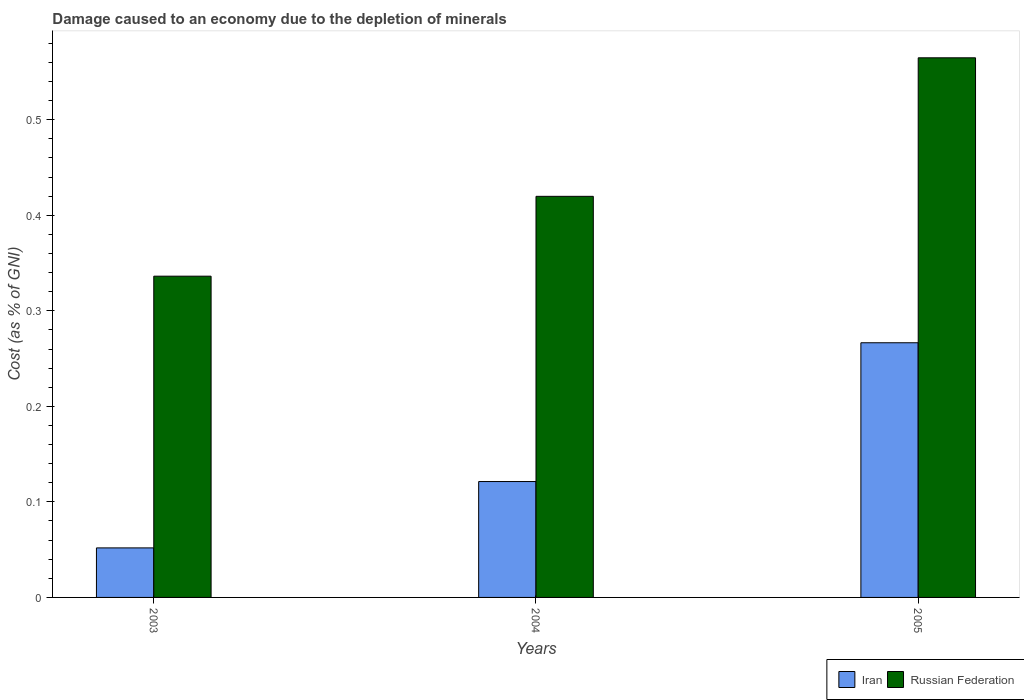How many groups of bars are there?
Give a very brief answer. 3. Are the number of bars per tick equal to the number of legend labels?
Make the answer very short. Yes. Are the number of bars on each tick of the X-axis equal?
Provide a short and direct response. Yes. What is the label of the 2nd group of bars from the left?
Offer a very short reply. 2004. In how many cases, is the number of bars for a given year not equal to the number of legend labels?
Your answer should be very brief. 0. What is the cost of damage caused due to the depletion of minerals in Iran in 2004?
Give a very brief answer. 0.12. Across all years, what is the maximum cost of damage caused due to the depletion of minerals in Russian Federation?
Provide a short and direct response. 0.56. Across all years, what is the minimum cost of damage caused due to the depletion of minerals in Russian Federation?
Provide a succinct answer. 0.34. What is the total cost of damage caused due to the depletion of minerals in Russian Federation in the graph?
Your response must be concise. 1.32. What is the difference between the cost of damage caused due to the depletion of minerals in Russian Federation in 2003 and that in 2005?
Offer a terse response. -0.23. What is the difference between the cost of damage caused due to the depletion of minerals in Russian Federation in 2003 and the cost of damage caused due to the depletion of minerals in Iran in 2004?
Offer a terse response. 0.21. What is the average cost of damage caused due to the depletion of minerals in Russian Federation per year?
Make the answer very short. 0.44. In the year 2003, what is the difference between the cost of damage caused due to the depletion of minerals in Iran and cost of damage caused due to the depletion of minerals in Russian Federation?
Provide a short and direct response. -0.28. In how many years, is the cost of damage caused due to the depletion of minerals in Russian Federation greater than 0.42000000000000004 %?
Keep it short and to the point. 1. What is the ratio of the cost of damage caused due to the depletion of minerals in Iran in 2003 to that in 2005?
Provide a short and direct response. 0.19. What is the difference between the highest and the second highest cost of damage caused due to the depletion of minerals in Russian Federation?
Offer a very short reply. 0.14. What is the difference between the highest and the lowest cost of damage caused due to the depletion of minerals in Russian Federation?
Provide a short and direct response. 0.23. What does the 2nd bar from the left in 2003 represents?
Offer a terse response. Russian Federation. What does the 2nd bar from the right in 2005 represents?
Keep it short and to the point. Iran. Are all the bars in the graph horizontal?
Make the answer very short. No. Are the values on the major ticks of Y-axis written in scientific E-notation?
Make the answer very short. No. Does the graph contain any zero values?
Ensure brevity in your answer.  No. Does the graph contain grids?
Offer a terse response. No. What is the title of the graph?
Your answer should be compact. Damage caused to an economy due to the depletion of minerals. Does "Chad" appear as one of the legend labels in the graph?
Keep it short and to the point. No. What is the label or title of the X-axis?
Your answer should be compact. Years. What is the label or title of the Y-axis?
Make the answer very short. Cost (as % of GNI). What is the Cost (as % of GNI) in Iran in 2003?
Keep it short and to the point. 0.05. What is the Cost (as % of GNI) in Russian Federation in 2003?
Your response must be concise. 0.34. What is the Cost (as % of GNI) in Iran in 2004?
Keep it short and to the point. 0.12. What is the Cost (as % of GNI) in Russian Federation in 2004?
Offer a terse response. 0.42. What is the Cost (as % of GNI) in Iran in 2005?
Make the answer very short. 0.27. What is the Cost (as % of GNI) in Russian Federation in 2005?
Offer a very short reply. 0.56. Across all years, what is the maximum Cost (as % of GNI) in Iran?
Provide a short and direct response. 0.27. Across all years, what is the maximum Cost (as % of GNI) of Russian Federation?
Provide a short and direct response. 0.56. Across all years, what is the minimum Cost (as % of GNI) in Iran?
Make the answer very short. 0.05. Across all years, what is the minimum Cost (as % of GNI) in Russian Federation?
Provide a succinct answer. 0.34. What is the total Cost (as % of GNI) of Iran in the graph?
Offer a very short reply. 0.44. What is the total Cost (as % of GNI) of Russian Federation in the graph?
Offer a very short reply. 1.32. What is the difference between the Cost (as % of GNI) of Iran in 2003 and that in 2004?
Make the answer very short. -0.07. What is the difference between the Cost (as % of GNI) of Russian Federation in 2003 and that in 2004?
Your answer should be very brief. -0.08. What is the difference between the Cost (as % of GNI) in Iran in 2003 and that in 2005?
Ensure brevity in your answer.  -0.21. What is the difference between the Cost (as % of GNI) of Russian Federation in 2003 and that in 2005?
Your response must be concise. -0.23. What is the difference between the Cost (as % of GNI) in Iran in 2004 and that in 2005?
Your answer should be compact. -0.15. What is the difference between the Cost (as % of GNI) in Russian Federation in 2004 and that in 2005?
Give a very brief answer. -0.14. What is the difference between the Cost (as % of GNI) of Iran in 2003 and the Cost (as % of GNI) of Russian Federation in 2004?
Ensure brevity in your answer.  -0.37. What is the difference between the Cost (as % of GNI) in Iran in 2003 and the Cost (as % of GNI) in Russian Federation in 2005?
Keep it short and to the point. -0.51. What is the difference between the Cost (as % of GNI) of Iran in 2004 and the Cost (as % of GNI) of Russian Federation in 2005?
Keep it short and to the point. -0.44. What is the average Cost (as % of GNI) of Iran per year?
Offer a very short reply. 0.15. What is the average Cost (as % of GNI) of Russian Federation per year?
Your answer should be compact. 0.44. In the year 2003, what is the difference between the Cost (as % of GNI) in Iran and Cost (as % of GNI) in Russian Federation?
Offer a very short reply. -0.28. In the year 2004, what is the difference between the Cost (as % of GNI) in Iran and Cost (as % of GNI) in Russian Federation?
Your answer should be very brief. -0.3. In the year 2005, what is the difference between the Cost (as % of GNI) in Iran and Cost (as % of GNI) in Russian Federation?
Keep it short and to the point. -0.3. What is the ratio of the Cost (as % of GNI) in Iran in 2003 to that in 2004?
Provide a succinct answer. 0.43. What is the ratio of the Cost (as % of GNI) in Russian Federation in 2003 to that in 2004?
Your answer should be very brief. 0.8. What is the ratio of the Cost (as % of GNI) in Iran in 2003 to that in 2005?
Your answer should be compact. 0.19. What is the ratio of the Cost (as % of GNI) of Russian Federation in 2003 to that in 2005?
Offer a terse response. 0.6. What is the ratio of the Cost (as % of GNI) in Iran in 2004 to that in 2005?
Provide a succinct answer. 0.46. What is the ratio of the Cost (as % of GNI) in Russian Federation in 2004 to that in 2005?
Keep it short and to the point. 0.74. What is the difference between the highest and the second highest Cost (as % of GNI) in Iran?
Your answer should be compact. 0.15. What is the difference between the highest and the second highest Cost (as % of GNI) in Russian Federation?
Give a very brief answer. 0.14. What is the difference between the highest and the lowest Cost (as % of GNI) of Iran?
Provide a short and direct response. 0.21. What is the difference between the highest and the lowest Cost (as % of GNI) of Russian Federation?
Your answer should be very brief. 0.23. 